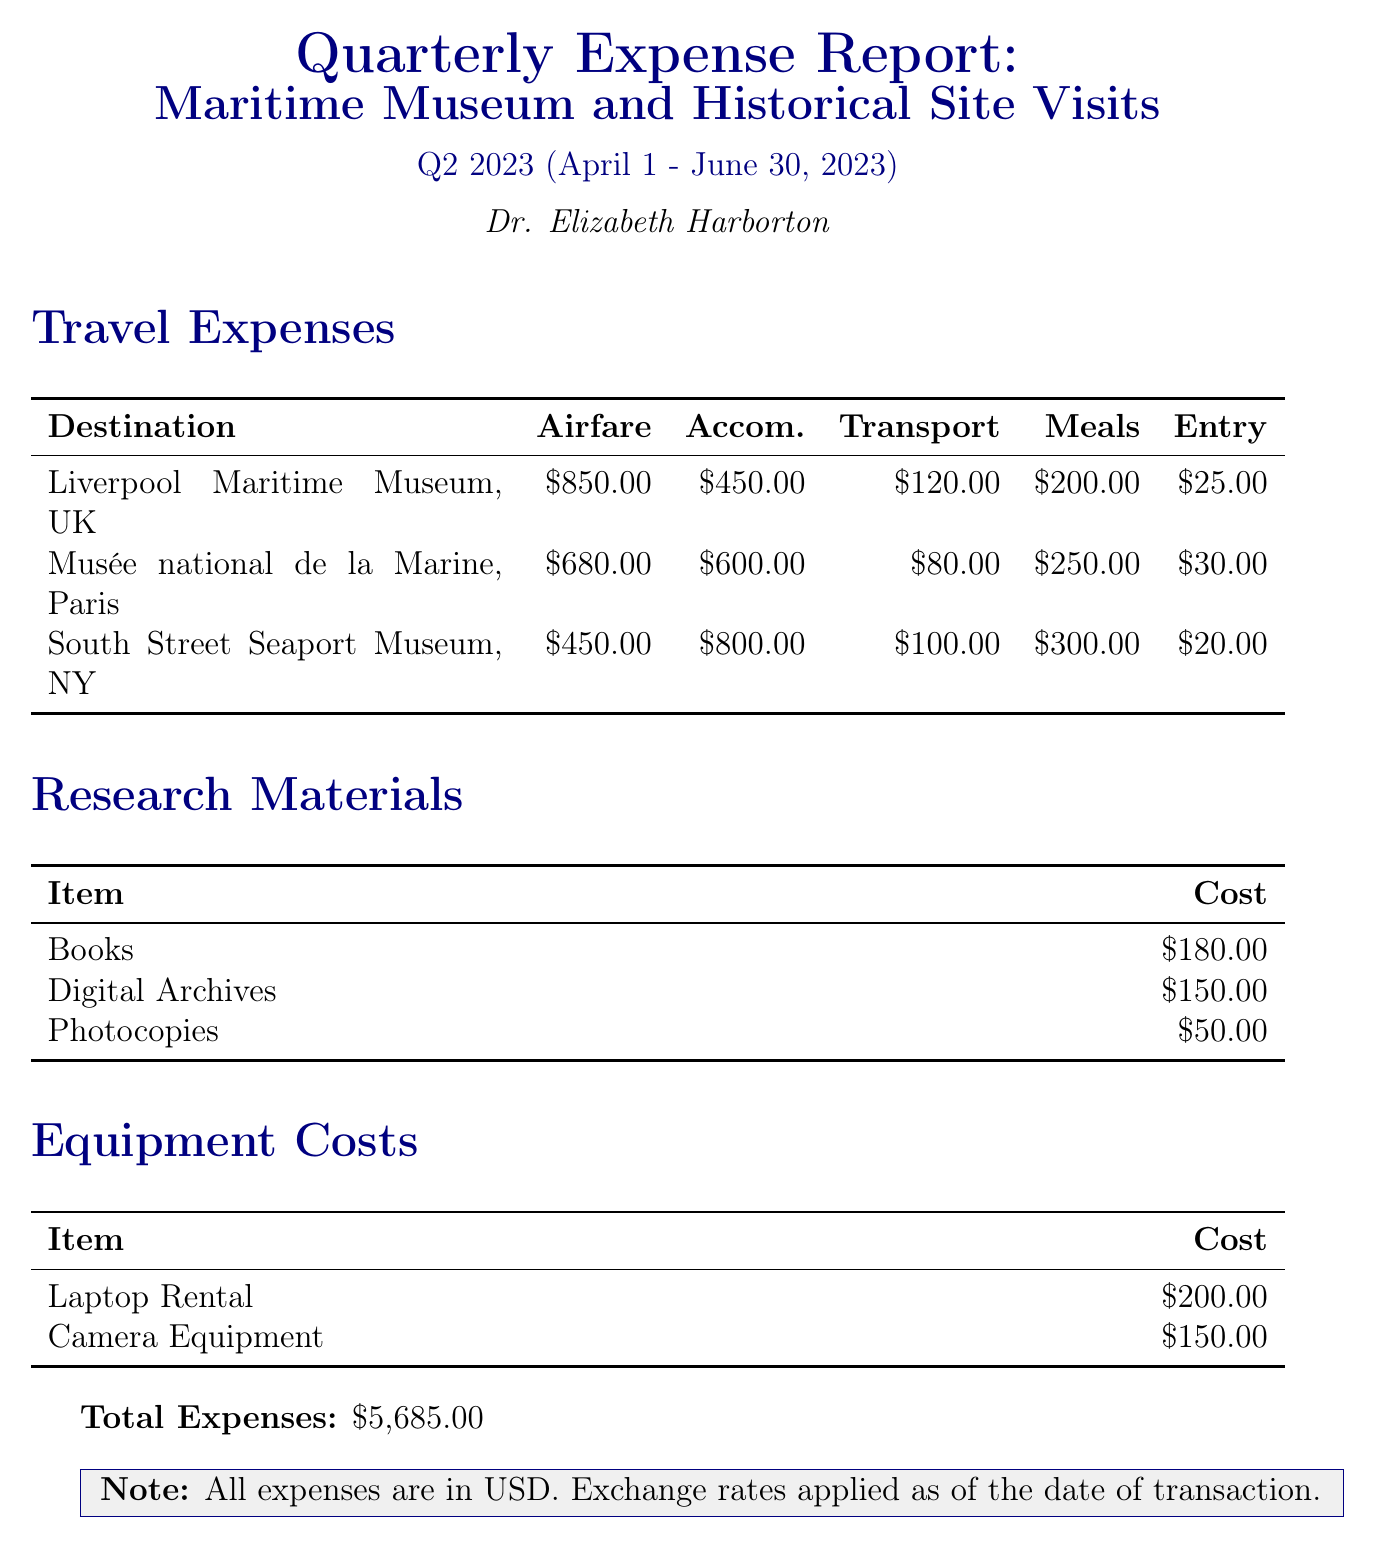what is the total amount of travel expenses? The total amount of travel expenses is the sum of all travel-related costs detailed in the report.
Answer: $5,685.00 who is the author of the report? The author's name is mentioned at the end of the title section of the report.
Answer: Dr. Elizabeth Harborton what was spent on meals during the visit to the Musée national de la Marine? The meals expense for the visit to the Musée national de la Marine can be found in the travel expenses section associated with that destination.
Answer: $250.00 which destination had the highest total expenses? The total expenses for each destination must be calculated to find which one is the highest. The destination with the highest sum is identified.
Answer: South Street Seaport Museum, New York, USA how much was spent on research materials? The total spent on research materials is the sum of all the listed items under that section of the report.
Answer: $380.00 what was the airfare for the Liverpool Maritime Museum? The airfare for the Liverpool Maritime Museum is explicitly stated in the travel expenses section.
Answer: $850.00 how much did the laptop rental cost? The cost of the laptop rental is listed under equipment costs.
Answer: $200.00 which country is the Musée national de la Marine located in? The country of the Musée national de la Marine is indicated in the travel expenses section.
Answer: France 